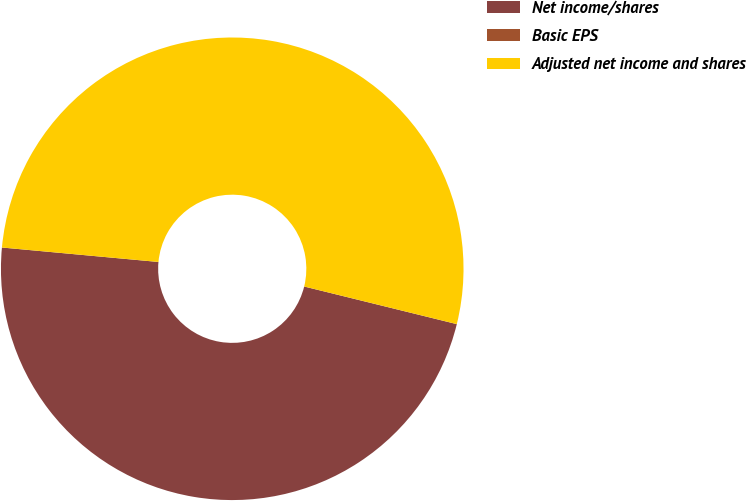Convert chart. <chart><loc_0><loc_0><loc_500><loc_500><pie_chart><fcel>Net income/shares<fcel>Basic EPS<fcel>Adjusted net income and shares<nl><fcel>47.62%<fcel>0.0%<fcel>52.38%<nl></chart> 